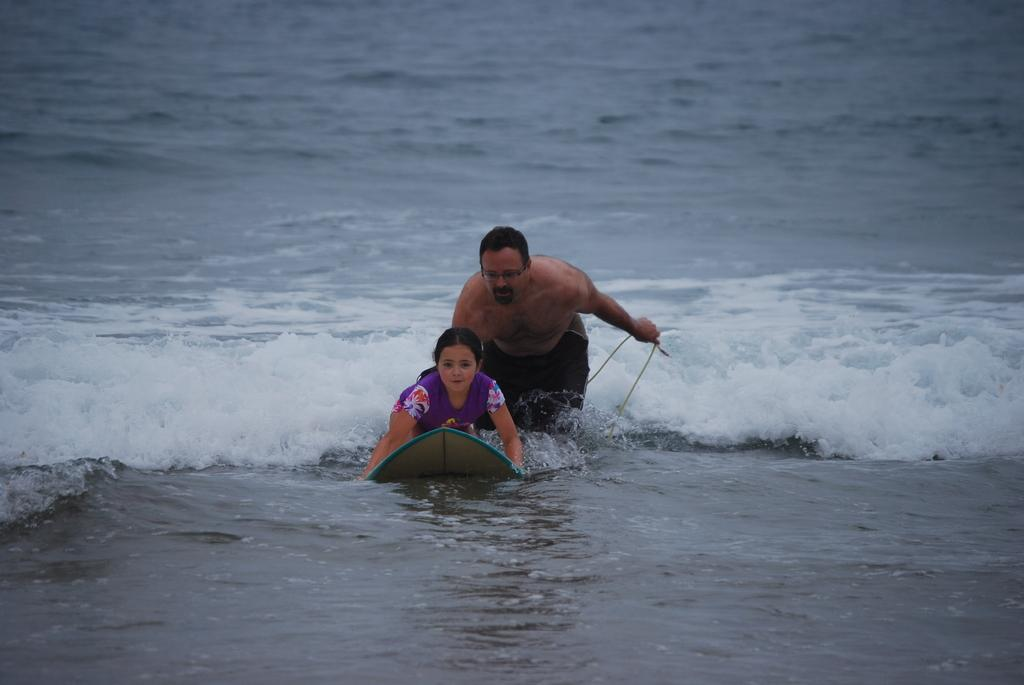Who is the main subject in the image? There is a girl in the image. What is the girl doing in the image? The girl is on a surfboard and surfing in the water. Can you describe the man in the image? The man is in the background. What type of dress is the fireman wearing in the image? There is no fireman present in the image, and therefore no dress can be observed. 